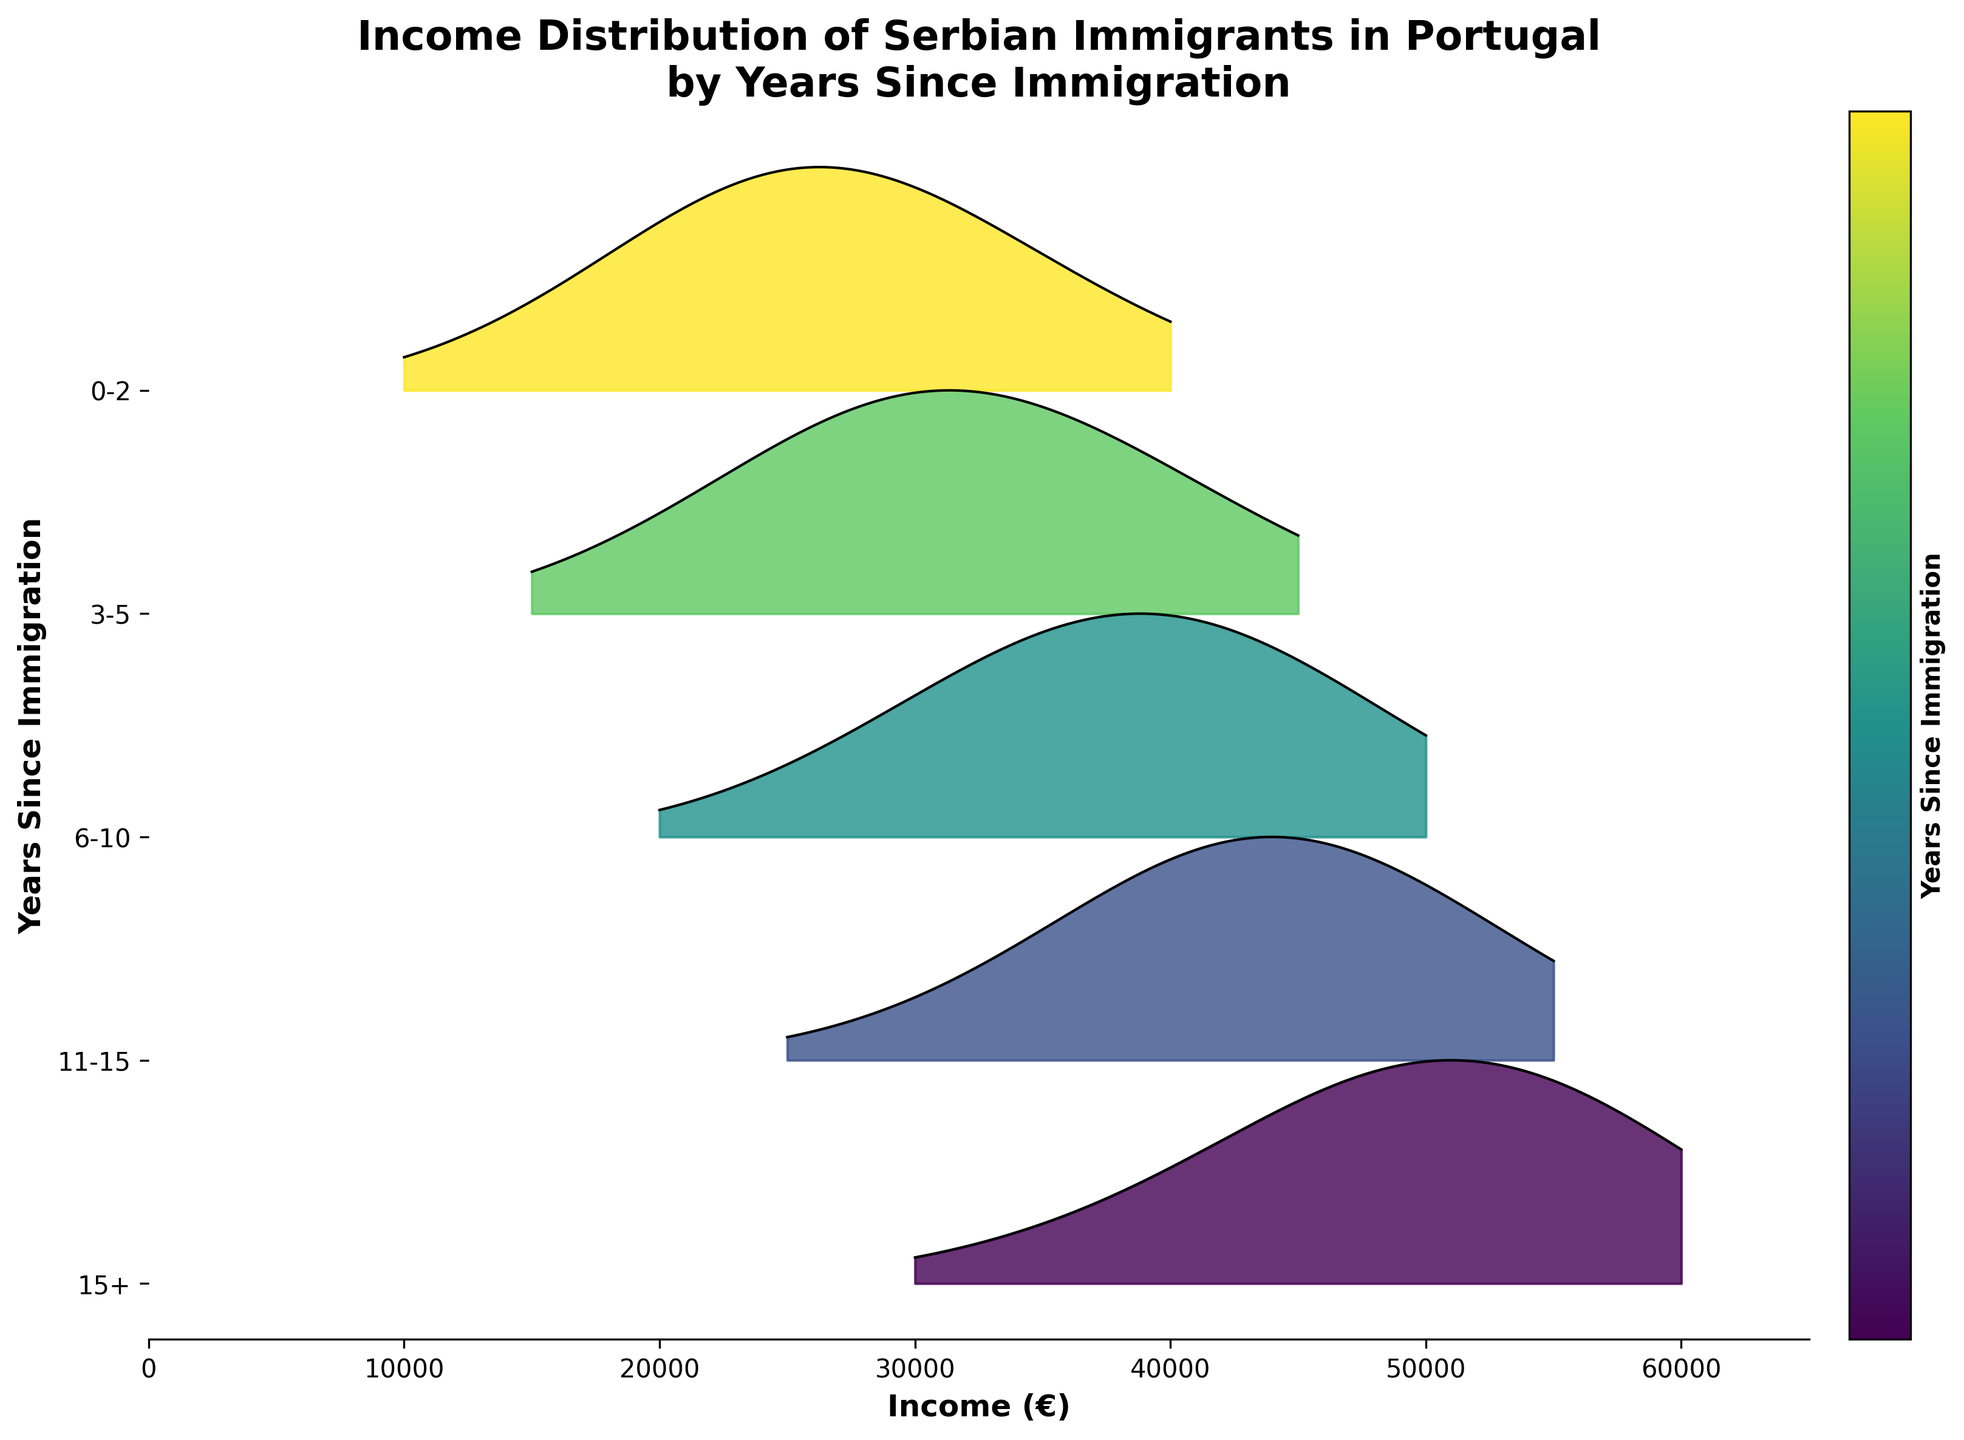what is the title of the plot? The title of a plot in a ridgeline plot is usually placed at the top center of the plot. This particular plot's title reads: "Income Distribution of Serbian Immigrants in Portugal by Years Since Immigration”.
Answer: Income Distribution of Serbian Immigrants in Portugal by Years Since Immigration How are the years since immigration represented in the plot? In this ridgeline plot, the years since immigration are represented on the y-axis using specific text labels for each group of years. The specific groups shown in this plot are "15+", "11-15", "6-10", "3-5", and "0-2".
Answer: On the y-axis, using text labels for each group of years For which group of years since immigration is the income density the highest at around 40,000€? To determine this, we look at the peaks of the density curves at around the income level of 40,000€. The group "6-10" has the highest density peak at this income level.
Answer: 6-10 Which group has the widest spread of income densities? To find the group with the widest spread, we observe the range covered by each density curve. The group "15+" appears to have the widest spread since it covers incomes from 30,000€ up to 60,000€.
Answer: 15+ How does the peak income density for the "0-2" and "3-5" groups compare? Comparing the peaks of the density curves, the group "3-5" has a higher peak income density than the "0-2" group, particularly around the 30,000-35,000€ range.
Answer: 3-5 has a higher peak income density Which group of years since immigration shows incomes above 50,000€? Incomes above 50,000€ appear in the density curves for the groups "11-15" and "15+". Examining the plot, it is clear that only these groups’ curves reach beyond 50,000€.
Answer: 11-15 and 15+ For the group "15+", what is the income range covered by the ridgeline plot? The ridgeline plot for the group "15+" covers incomes ranging from around 30,000€ to 60,000€. This can be seen by the span of the density curve for this group, which starts at 30,000€ and extends to 60,000€.
Answer: 30,000€ to 60,000€ Among the groups "6-10" and "11-15", which one has a higher income density around 45,000€? To compare the income densities around 45,000€, we evaluate the heights of the density curves at this point. The group "6-10" has a lower density than "11-15" around 45,000€.
Answer: 11-15 Which color represents the earliest group of years since immigration? In the color gradient produced from the ridgeline plot, the earliest group "0-2" is likely represented by the lightest color at the bottom of the gradient.
Answer: Lightest color What's the general trend of income density as years since immigration increases? Observing the ridgeline plot, it can be inferred that as years since immigration increase, the income density shifts towards higher income ranges and higher densities. This is evident from the position and height of the curves for groups with more years since immigration.
Answer: Higher income ranges and higher densities 